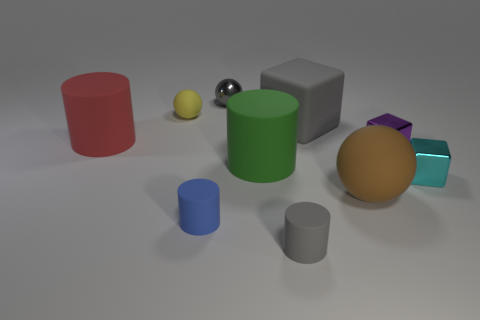How many metal objects are the same color as the matte cube?
Provide a short and direct response. 1. There is a thing on the left side of the sphere that is on the left side of the blue object; what is its size?
Keep it short and to the point. Large. What number of things are tiny things that are behind the large brown sphere or gray things?
Your response must be concise. 6. Is there a yellow ball of the same size as the cyan metallic thing?
Your answer should be compact. Yes. There is a small gray object that is in front of the big red cylinder; is there a small cyan thing that is in front of it?
Offer a terse response. No. How many cylinders are either tiny green metallic things or big green matte objects?
Provide a succinct answer. 1. Is there a tiny blue object that has the same shape as the red thing?
Your answer should be very brief. Yes. What is the shape of the small cyan metallic object?
Provide a succinct answer. Cube. What number of objects are big red balls or small blocks?
Provide a succinct answer. 2. Does the sphere that is to the right of the gray ball have the same size as the shiny thing behind the red rubber object?
Provide a succinct answer. No. 